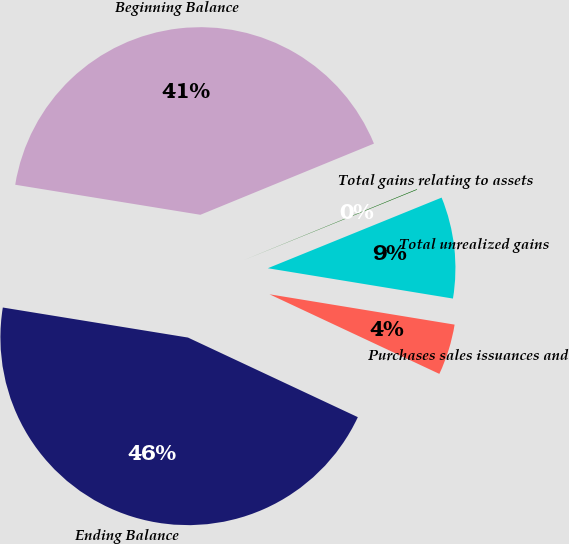Convert chart to OTSL. <chart><loc_0><loc_0><loc_500><loc_500><pie_chart><fcel>Beginning Balance<fcel>Total gains relating to assets<fcel>Total unrealized gains<fcel>Purchases sales issuances and<fcel>Ending Balance<nl><fcel>41.25%<fcel>0.05%<fcel>8.73%<fcel>4.39%<fcel>45.59%<nl></chart> 